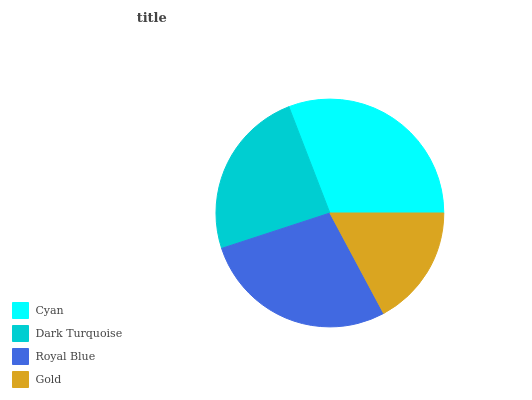Is Gold the minimum?
Answer yes or no. Yes. Is Cyan the maximum?
Answer yes or no. Yes. Is Dark Turquoise the minimum?
Answer yes or no. No. Is Dark Turquoise the maximum?
Answer yes or no. No. Is Cyan greater than Dark Turquoise?
Answer yes or no. Yes. Is Dark Turquoise less than Cyan?
Answer yes or no. Yes. Is Dark Turquoise greater than Cyan?
Answer yes or no. No. Is Cyan less than Dark Turquoise?
Answer yes or no. No. Is Royal Blue the high median?
Answer yes or no. Yes. Is Dark Turquoise the low median?
Answer yes or no. Yes. Is Dark Turquoise the high median?
Answer yes or no. No. Is Gold the low median?
Answer yes or no. No. 